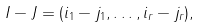Convert formula to latex. <formula><loc_0><loc_0><loc_500><loc_500>I - J = ( i _ { 1 } - j _ { 1 } , \dots , i _ { r } - j _ { r } ) ,</formula> 